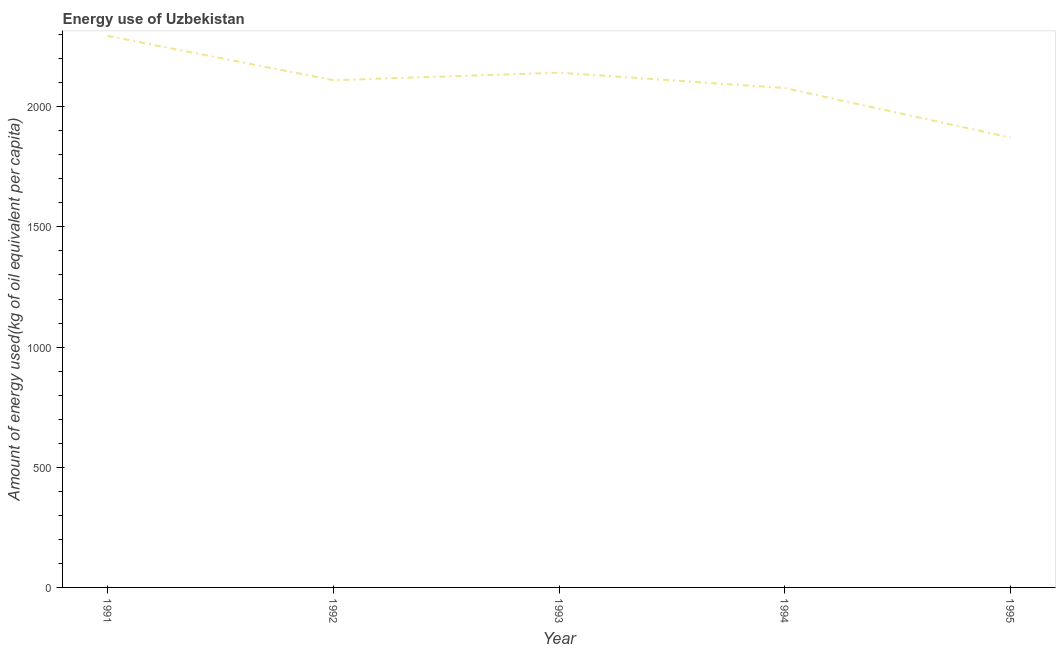What is the amount of energy used in 1994?
Ensure brevity in your answer.  2077.89. Across all years, what is the maximum amount of energy used?
Ensure brevity in your answer.  2294.82. Across all years, what is the minimum amount of energy used?
Give a very brief answer. 1871.85. What is the sum of the amount of energy used?
Your response must be concise. 1.05e+04. What is the difference between the amount of energy used in 1992 and 1993?
Give a very brief answer. -31.44. What is the average amount of energy used per year?
Provide a short and direct response. 2099.4. What is the median amount of energy used?
Provide a short and direct response. 2110.5. In how many years, is the amount of energy used greater than 2100 kg?
Ensure brevity in your answer.  3. What is the ratio of the amount of energy used in 1993 to that in 1994?
Give a very brief answer. 1.03. What is the difference between the highest and the second highest amount of energy used?
Provide a succinct answer. 152.89. What is the difference between the highest and the lowest amount of energy used?
Give a very brief answer. 422.97. In how many years, is the amount of energy used greater than the average amount of energy used taken over all years?
Your answer should be very brief. 3. Does the amount of energy used monotonically increase over the years?
Your answer should be compact. No. How many lines are there?
Keep it short and to the point. 1. Does the graph contain grids?
Keep it short and to the point. No. What is the title of the graph?
Make the answer very short. Energy use of Uzbekistan. What is the label or title of the Y-axis?
Offer a very short reply. Amount of energy used(kg of oil equivalent per capita). What is the Amount of energy used(kg of oil equivalent per capita) in 1991?
Your answer should be compact. 2294.82. What is the Amount of energy used(kg of oil equivalent per capita) in 1992?
Keep it short and to the point. 2110.5. What is the Amount of energy used(kg of oil equivalent per capita) in 1993?
Offer a very short reply. 2141.93. What is the Amount of energy used(kg of oil equivalent per capita) in 1994?
Your answer should be compact. 2077.89. What is the Amount of energy used(kg of oil equivalent per capita) of 1995?
Keep it short and to the point. 1871.85. What is the difference between the Amount of energy used(kg of oil equivalent per capita) in 1991 and 1992?
Provide a succinct answer. 184.33. What is the difference between the Amount of energy used(kg of oil equivalent per capita) in 1991 and 1993?
Keep it short and to the point. 152.89. What is the difference between the Amount of energy used(kg of oil equivalent per capita) in 1991 and 1994?
Your answer should be very brief. 216.93. What is the difference between the Amount of energy used(kg of oil equivalent per capita) in 1991 and 1995?
Provide a succinct answer. 422.97. What is the difference between the Amount of energy used(kg of oil equivalent per capita) in 1992 and 1993?
Provide a short and direct response. -31.44. What is the difference between the Amount of energy used(kg of oil equivalent per capita) in 1992 and 1994?
Offer a terse response. 32.6. What is the difference between the Amount of energy used(kg of oil equivalent per capita) in 1992 and 1995?
Make the answer very short. 238.64. What is the difference between the Amount of energy used(kg of oil equivalent per capita) in 1993 and 1994?
Make the answer very short. 64.04. What is the difference between the Amount of energy used(kg of oil equivalent per capita) in 1993 and 1995?
Your answer should be very brief. 270.08. What is the difference between the Amount of energy used(kg of oil equivalent per capita) in 1994 and 1995?
Your response must be concise. 206.04. What is the ratio of the Amount of energy used(kg of oil equivalent per capita) in 1991 to that in 1992?
Provide a succinct answer. 1.09. What is the ratio of the Amount of energy used(kg of oil equivalent per capita) in 1991 to that in 1993?
Your answer should be compact. 1.07. What is the ratio of the Amount of energy used(kg of oil equivalent per capita) in 1991 to that in 1994?
Offer a terse response. 1.1. What is the ratio of the Amount of energy used(kg of oil equivalent per capita) in 1991 to that in 1995?
Offer a terse response. 1.23. What is the ratio of the Amount of energy used(kg of oil equivalent per capita) in 1992 to that in 1993?
Provide a succinct answer. 0.98. What is the ratio of the Amount of energy used(kg of oil equivalent per capita) in 1992 to that in 1995?
Ensure brevity in your answer.  1.13. What is the ratio of the Amount of energy used(kg of oil equivalent per capita) in 1993 to that in 1994?
Ensure brevity in your answer.  1.03. What is the ratio of the Amount of energy used(kg of oil equivalent per capita) in 1993 to that in 1995?
Your response must be concise. 1.14. What is the ratio of the Amount of energy used(kg of oil equivalent per capita) in 1994 to that in 1995?
Keep it short and to the point. 1.11. 